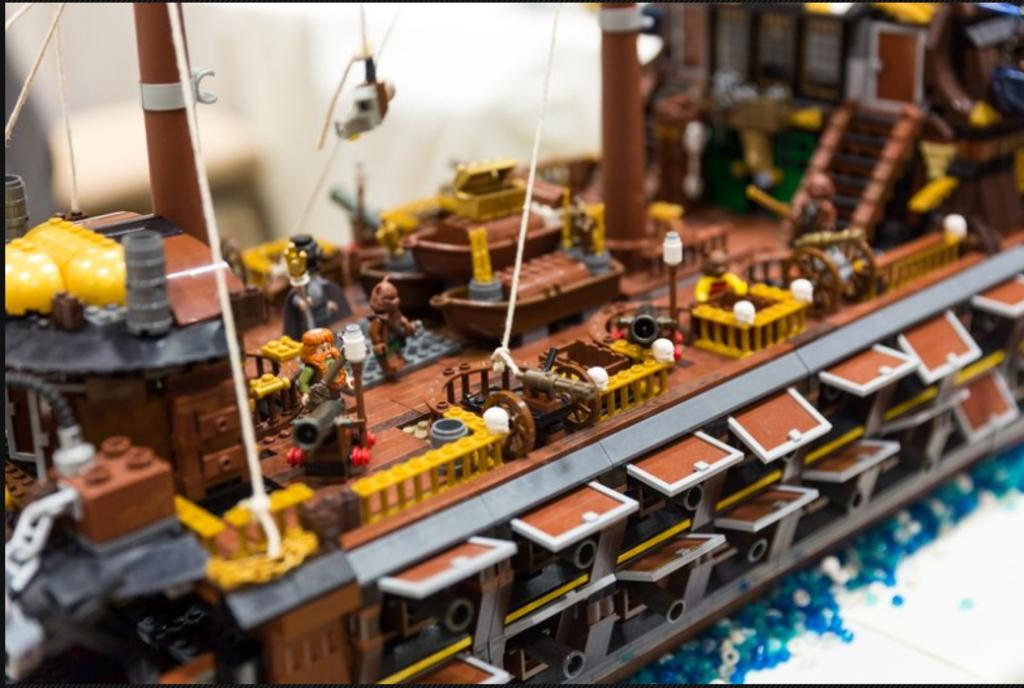What type of objects are made from building blocks in the image? There are toys made of building blocks in the image. What else can be seen in the image besides the building block toys? There are threads visible in the image. Can you describe the background of the image? The background of the image is blurry. What type of bean is present in the image? There is no bean present in the image. How does the water affect the building block toys in the image? There is no water present in the image, so it does not affect the building block toys. 